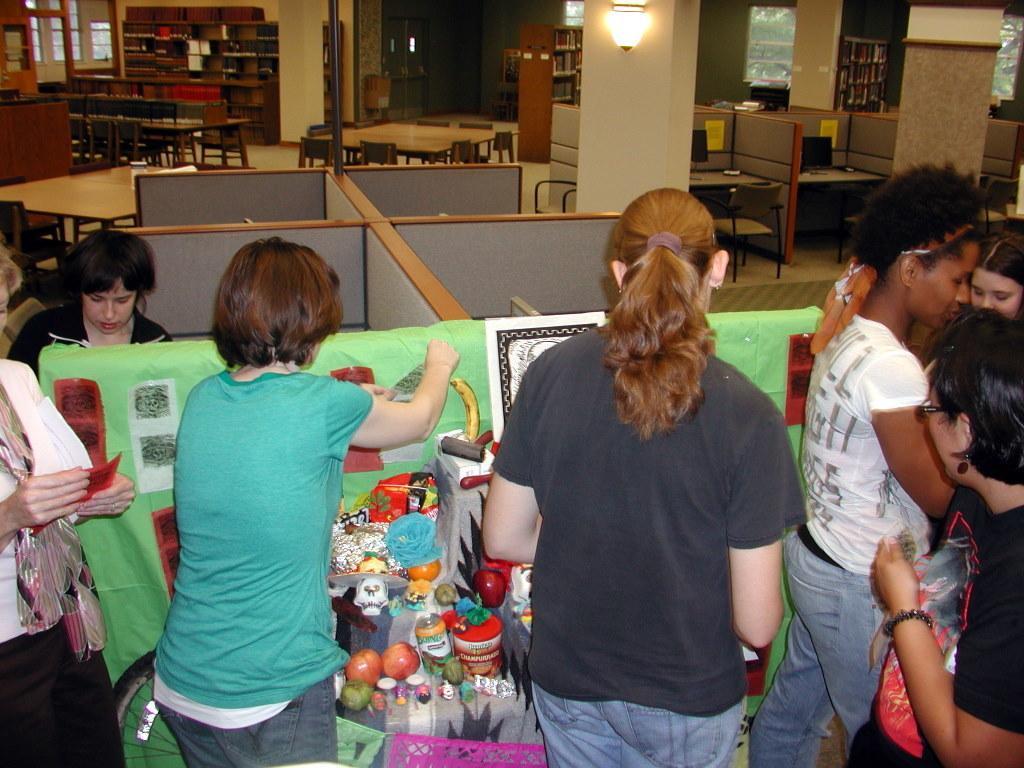How would you summarize this image in a sentence or two? In this image we can see some persons, fruits, papers, cabins and other objects. In the background of the image there are shelves, tables, chairs, light, pillar, wall, windows and other objects. 